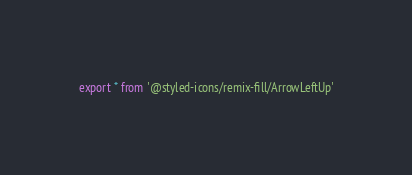<code> <loc_0><loc_0><loc_500><loc_500><_TypeScript_>export * from '@styled-icons/remix-fill/ArrowLeftUp'</code> 